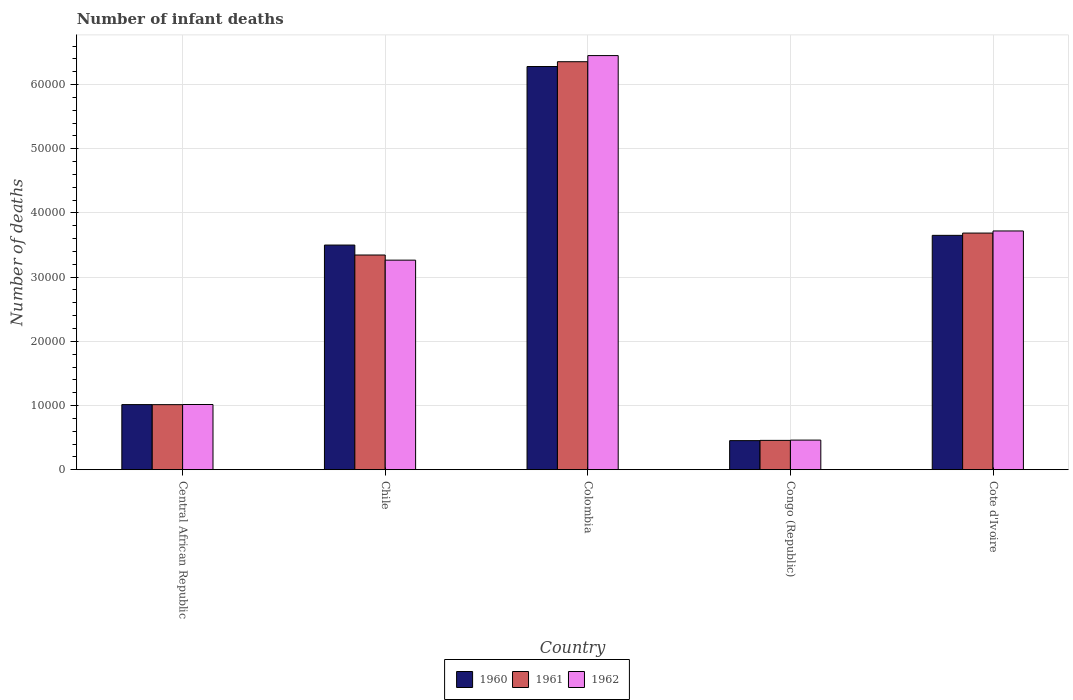How many groups of bars are there?
Keep it short and to the point. 5. Are the number of bars on each tick of the X-axis equal?
Your answer should be compact. Yes. In how many cases, is the number of bars for a given country not equal to the number of legend labels?
Keep it short and to the point. 0. What is the number of infant deaths in 1960 in Cote d'Ivoire?
Your response must be concise. 3.65e+04. Across all countries, what is the maximum number of infant deaths in 1961?
Offer a very short reply. 6.36e+04. Across all countries, what is the minimum number of infant deaths in 1960?
Ensure brevity in your answer.  4529. In which country was the number of infant deaths in 1960 maximum?
Provide a short and direct response. Colombia. In which country was the number of infant deaths in 1961 minimum?
Give a very brief answer. Congo (Republic). What is the total number of infant deaths in 1962 in the graph?
Offer a terse response. 1.49e+05. What is the difference between the number of infant deaths in 1962 in Chile and that in Colombia?
Ensure brevity in your answer.  -3.19e+04. What is the difference between the number of infant deaths in 1960 in Cote d'Ivoire and the number of infant deaths in 1962 in Congo (Republic)?
Your response must be concise. 3.19e+04. What is the average number of infant deaths in 1961 per country?
Your answer should be very brief. 2.97e+04. What is the difference between the number of infant deaths of/in 1962 and number of infant deaths of/in 1960 in Chile?
Ensure brevity in your answer.  -2350. In how many countries, is the number of infant deaths in 1960 greater than 22000?
Your answer should be compact. 3. What is the ratio of the number of infant deaths in 1962 in Central African Republic to that in Congo (Republic)?
Offer a very short reply. 2.2. What is the difference between the highest and the second highest number of infant deaths in 1961?
Offer a terse response. 3.01e+04. What is the difference between the highest and the lowest number of infant deaths in 1962?
Offer a terse response. 5.99e+04. In how many countries, is the number of infant deaths in 1960 greater than the average number of infant deaths in 1960 taken over all countries?
Ensure brevity in your answer.  3. What does the 2nd bar from the left in Congo (Republic) represents?
Your response must be concise. 1961. Is it the case that in every country, the sum of the number of infant deaths in 1960 and number of infant deaths in 1962 is greater than the number of infant deaths in 1961?
Provide a succinct answer. Yes. How many bars are there?
Your answer should be compact. 15. How many countries are there in the graph?
Make the answer very short. 5. Does the graph contain grids?
Your answer should be compact. Yes. How are the legend labels stacked?
Your answer should be compact. Horizontal. What is the title of the graph?
Make the answer very short. Number of infant deaths. What is the label or title of the X-axis?
Keep it short and to the point. Country. What is the label or title of the Y-axis?
Your response must be concise. Number of deaths. What is the Number of deaths in 1960 in Central African Republic?
Offer a very short reply. 1.01e+04. What is the Number of deaths of 1961 in Central African Republic?
Offer a terse response. 1.01e+04. What is the Number of deaths in 1962 in Central African Republic?
Give a very brief answer. 1.02e+04. What is the Number of deaths in 1960 in Chile?
Your answer should be compact. 3.50e+04. What is the Number of deaths in 1961 in Chile?
Your answer should be compact. 3.35e+04. What is the Number of deaths of 1962 in Chile?
Offer a terse response. 3.27e+04. What is the Number of deaths in 1960 in Colombia?
Offer a terse response. 6.28e+04. What is the Number of deaths in 1961 in Colombia?
Your answer should be very brief. 6.36e+04. What is the Number of deaths in 1962 in Colombia?
Ensure brevity in your answer.  6.45e+04. What is the Number of deaths in 1960 in Congo (Republic)?
Your answer should be compact. 4529. What is the Number of deaths of 1961 in Congo (Republic)?
Provide a short and direct response. 4567. What is the Number of deaths of 1962 in Congo (Republic)?
Give a very brief answer. 4612. What is the Number of deaths in 1960 in Cote d'Ivoire?
Provide a succinct answer. 3.65e+04. What is the Number of deaths in 1961 in Cote d'Ivoire?
Offer a terse response. 3.69e+04. What is the Number of deaths of 1962 in Cote d'Ivoire?
Offer a terse response. 3.72e+04. Across all countries, what is the maximum Number of deaths in 1960?
Your answer should be compact. 6.28e+04. Across all countries, what is the maximum Number of deaths of 1961?
Your response must be concise. 6.36e+04. Across all countries, what is the maximum Number of deaths of 1962?
Offer a very short reply. 6.45e+04. Across all countries, what is the minimum Number of deaths in 1960?
Give a very brief answer. 4529. Across all countries, what is the minimum Number of deaths of 1961?
Provide a succinct answer. 4567. Across all countries, what is the minimum Number of deaths of 1962?
Your answer should be very brief. 4612. What is the total Number of deaths of 1960 in the graph?
Your answer should be compact. 1.49e+05. What is the total Number of deaths of 1961 in the graph?
Your answer should be very brief. 1.49e+05. What is the total Number of deaths in 1962 in the graph?
Make the answer very short. 1.49e+05. What is the difference between the Number of deaths of 1960 in Central African Republic and that in Chile?
Keep it short and to the point. -2.49e+04. What is the difference between the Number of deaths of 1961 in Central African Republic and that in Chile?
Provide a short and direct response. -2.33e+04. What is the difference between the Number of deaths in 1962 in Central African Republic and that in Chile?
Provide a short and direct response. -2.25e+04. What is the difference between the Number of deaths in 1960 in Central African Republic and that in Colombia?
Keep it short and to the point. -5.27e+04. What is the difference between the Number of deaths in 1961 in Central African Republic and that in Colombia?
Offer a very short reply. -5.34e+04. What is the difference between the Number of deaths of 1962 in Central African Republic and that in Colombia?
Offer a very short reply. -5.44e+04. What is the difference between the Number of deaths in 1960 in Central African Republic and that in Congo (Republic)?
Provide a short and direct response. 5615. What is the difference between the Number of deaths in 1961 in Central African Republic and that in Congo (Republic)?
Your answer should be very brief. 5568. What is the difference between the Number of deaths in 1962 in Central African Republic and that in Congo (Republic)?
Your answer should be very brief. 5545. What is the difference between the Number of deaths of 1960 in Central African Republic and that in Cote d'Ivoire?
Provide a succinct answer. -2.64e+04. What is the difference between the Number of deaths in 1961 in Central African Republic and that in Cote d'Ivoire?
Make the answer very short. -2.67e+04. What is the difference between the Number of deaths of 1962 in Central African Republic and that in Cote d'Ivoire?
Ensure brevity in your answer.  -2.70e+04. What is the difference between the Number of deaths in 1960 in Chile and that in Colombia?
Make the answer very short. -2.78e+04. What is the difference between the Number of deaths in 1961 in Chile and that in Colombia?
Give a very brief answer. -3.01e+04. What is the difference between the Number of deaths in 1962 in Chile and that in Colombia?
Ensure brevity in your answer.  -3.19e+04. What is the difference between the Number of deaths of 1960 in Chile and that in Congo (Republic)?
Your answer should be compact. 3.05e+04. What is the difference between the Number of deaths of 1961 in Chile and that in Congo (Republic)?
Offer a very short reply. 2.89e+04. What is the difference between the Number of deaths of 1962 in Chile and that in Congo (Republic)?
Your answer should be very brief. 2.80e+04. What is the difference between the Number of deaths in 1960 in Chile and that in Cote d'Ivoire?
Your response must be concise. -1514. What is the difference between the Number of deaths in 1961 in Chile and that in Cote d'Ivoire?
Your answer should be very brief. -3418. What is the difference between the Number of deaths in 1962 in Chile and that in Cote d'Ivoire?
Ensure brevity in your answer.  -4547. What is the difference between the Number of deaths in 1960 in Colombia and that in Congo (Republic)?
Provide a short and direct response. 5.83e+04. What is the difference between the Number of deaths in 1961 in Colombia and that in Congo (Republic)?
Give a very brief answer. 5.90e+04. What is the difference between the Number of deaths of 1962 in Colombia and that in Congo (Republic)?
Give a very brief answer. 5.99e+04. What is the difference between the Number of deaths in 1960 in Colombia and that in Cote d'Ivoire?
Your answer should be compact. 2.63e+04. What is the difference between the Number of deaths of 1961 in Colombia and that in Cote d'Ivoire?
Provide a succinct answer. 2.67e+04. What is the difference between the Number of deaths of 1962 in Colombia and that in Cote d'Ivoire?
Offer a very short reply. 2.73e+04. What is the difference between the Number of deaths of 1960 in Congo (Republic) and that in Cote d'Ivoire?
Ensure brevity in your answer.  -3.20e+04. What is the difference between the Number of deaths in 1961 in Congo (Republic) and that in Cote d'Ivoire?
Provide a short and direct response. -3.23e+04. What is the difference between the Number of deaths of 1962 in Congo (Republic) and that in Cote d'Ivoire?
Your answer should be very brief. -3.26e+04. What is the difference between the Number of deaths in 1960 in Central African Republic and the Number of deaths in 1961 in Chile?
Provide a succinct answer. -2.33e+04. What is the difference between the Number of deaths of 1960 in Central African Republic and the Number of deaths of 1962 in Chile?
Ensure brevity in your answer.  -2.25e+04. What is the difference between the Number of deaths of 1961 in Central African Republic and the Number of deaths of 1962 in Chile?
Offer a very short reply. -2.25e+04. What is the difference between the Number of deaths of 1960 in Central African Republic and the Number of deaths of 1961 in Colombia?
Your answer should be compact. -5.34e+04. What is the difference between the Number of deaths of 1960 in Central African Republic and the Number of deaths of 1962 in Colombia?
Your answer should be very brief. -5.44e+04. What is the difference between the Number of deaths in 1961 in Central African Republic and the Number of deaths in 1962 in Colombia?
Offer a terse response. -5.44e+04. What is the difference between the Number of deaths in 1960 in Central African Republic and the Number of deaths in 1961 in Congo (Republic)?
Offer a terse response. 5577. What is the difference between the Number of deaths of 1960 in Central African Republic and the Number of deaths of 1962 in Congo (Republic)?
Your answer should be very brief. 5532. What is the difference between the Number of deaths in 1961 in Central African Republic and the Number of deaths in 1962 in Congo (Republic)?
Keep it short and to the point. 5523. What is the difference between the Number of deaths in 1960 in Central African Republic and the Number of deaths in 1961 in Cote d'Ivoire?
Ensure brevity in your answer.  -2.67e+04. What is the difference between the Number of deaths of 1960 in Central African Republic and the Number of deaths of 1962 in Cote d'Ivoire?
Give a very brief answer. -2.71e+04. What is the difference between the Number of deaths in 1961 in Central African Republic and the Number of deaths in 1962 in Cote d'Ivoire?
Make the answer very short. -2.71e+04. What is the difference between the Number of deaths in 1960 in Chile and the Number of deaths in 1961 in Colombia?
Offer a very short reply. -2.86e+04. What is the difference between the Number of deaths in 1960 in Chile and the Number of deaths in 1962 in Colombia?
Your answer should be compact. -2.95e+04. What is the difference between the Number of deaths of 1961 in Chile and the Number of deaths of 1962 in Colombia?
Your answer should be compact. -3.11e+04. What is the difference between the Number of deaths of 1960 in Chile and the Number of deaths of 1961 in Congo (Republic)?
Give a very brief answer. 3.04e+04. What is the difference between the Number of deaths of 1960 in Chile and the Number of deaths of 1962 in Congo (Republic)?
Offer a very short reply. 3.04e+04. What is the difference between the Number of deaths in 1961 in Chile and the Number of deaths in 1962 in Congo (Republic)?
Your answer should be compact. 2.88e+04. What is the difference between the Number of deaths of 1960 in Chile and the Number of deaths of 1961 in Cote d'Ivoire?
Offer a terse response. -1869. What is the difference between the Number of deaths of 1960 in Chile and the Number of deaths of 1962 in Cote d'Ivoire?
Make the answer very short. -2197. What is the difference between the Number of deaths in 1961 in Chile and the Number of deaths in 1962 in Cote d'Ivoire?
Keep it short and to the point. -3746. What is the difference between the Number of deaths of 1960 in Colombia and the Number of deaths of 1961 in Congo (Republic)?
Provide a succinct answer. 5.83e+04. What is the difference between the Number of deaths in 1960 in Colombia and the Number of deaths in 1962 in Congo (Republic)?
Provide a succinct answer. 5.82e+04. What is the difference between the Number of deaths in 1961 in Colombia and the Number of deaths in 1962 in Congo (Republic)?
Offer a very short reply. 5.90e+04. What is the difference between the Number of deaths of 1960 in Colombia and the Number of deaths of 1961 in Cote d'Ivoire?
Make the answer very short. 2.60e+04. What is the difference between the Number of deaths of 1960 in Colombia and the Number of deaths of 1962 in Cote d'Ivoire?
Your answer should be very brief. 2.56e+04. What is the difference between the Number of deaths of 1961 in Colombia and the Number of deaths of 1962 in Cote d'Ivoire?
Provide a succinct answer. 2.64e+04. What is the difference between the Number of deaths in 1960 in Congo (Republic) and the Number of deaths in 1961 in Cote d'Ivoire?
Your answer should be compact. -3.23e+04. What is the difference between the Number of deaths in 1960 in Congo (Republic) and the Number of deaths in 1962 in Cote d'Ivoire?
Offer a very short reply. -3.27e+04. What is the difference between the Number of deaths of 1961 in Congo (Republic) and the Number of deaths of 1962 in Cote d'Ivoire?
Your answer should be compact. -3.26e+04. What is the average Number of deaths in 1960 per country?
Your answer should be very brief. 2.98e+04. What is the average Number of deaths of 1961 per country?
Offer a terse response. 2.97e+04. What is the average Number of deaths of 1962 per country?
Your answer should be very brief. 2.98e+04. What is the difference between the Number of deaths of 1960 and Number of deaths of 1961 in Central African Republic?
Offer a terse response. 9. What is the difference between the Number of deaths in 1961 and Number of deaths in 1962 in Central African Republic?
Provide a succinct answer. -22. What is the difference between the Number of deaths in 1960 and Number of deaths in 1961 in Chile?
Your answer should be very brief. 1549. What is the difference between the Number of deaths of 1960 and Number of deaths of 1962 in Chile?
Make the answer very short. 2350. What is the difference between the Number of deaths of 1961 and Number of deaths of 1962 in Chile?
Your response must be concise. 801. What is the difference between the Number of deaths of 1960 and Number of deaths of 1961 in Colombia?
Make the answer very short. -749. What is the difference between the Number of deaths in 1960 and Number of deaths in 1962 in Colombia?
Ensure brevity in your answer.  -1705. What is the difference between the Number of deaths in 1961 and Number of deaths in 1962 in Colombia?
Offer a terse response. -956. What is the difference between the Number of deaths in 1960 and Number of deaths in 1961 in Congo (Republic)?
Keep it short and to the point. -38. What is the difference between the Number of deaths of 1960 and Number of deaths of 1962 in Congo (Republic)?
Your response must be concise. -83. What is the difference between the Number of deaths in 1961 and Number of deaths in 1962 in Congo (Republic)?
Offer a terse response. -45. What is the difference between the Number of deaths of 1960 and Number of deaths of 1961 in Cote d'Ivoire?
Provide a succinct answer. -355. What is the difference between the Number of deaths in 1960 and Number of deaths in 1962 in Cote d'Ivoire?
Offer a very short reply. -683. What is the difference between the Number of deaths in 1961 and Number of deaths in 1962 in Cote d'Ivoire?
Your answer should be very brief. -328. What is the ratio of the Number of deaths of 1960 in Central African Republic to that in Chile?
Give a very brief answer. 0.29. What is the ratio of the Number of deaths of 1961 in Central African Republic to that in Chile?
Offer a very short reply. 0.3. What is the ratio of the Number of deaths in 1962 in Central African Republic to that in Chile?
Your answer should be very brief. 0.31. What is the ratio of the Number of deaths of 1960 in Central African Republic to that in Colombia?
Provide a short and direct response. 0.16. What is the ratio of the Number of deaths in 1961 in Central African Republic to that in Colombia?
Give a very brief answer. 0.16. What is the ratio of the Number of deaths in 1962 in Central African Republic to that in Colombia?
Your answer should be compact. 0.16. What is the ratio of the Number of deaths of 1960 in Central African Republic to that in Congo (Republic)?
Ensure brevity in your answer.  2.24. What is the ratio of the Number of deaths in 1961 in Central African Republic to that in Congo (Republic)?
Provide a succinct answer. 2.22. What is the ratio of the Number of deaths of 1962 in Central African Republic to that in Congo (Republic)?
Your answer should be very brief. 2.2. What is the ratio of the Number of deaths in 1960 in Central African Republic to that in Cote d'Ivoire?
Your answer should be compact. 0.28. What is the ratio of the Number of deaths in 1961 in Central African Republic to that in Cote d'Ivoire?
Your answer should be very brief. 0.27. What is the ratio of the Number of deaths in 1962 in Central African Republic to that in Cote d'Ivoire?
Give a very brief answer. 0.27. What is the ratio of the Number of deaths in 1960 in Chile to that in Colombia?
Give a very brief answer. 0.56. What is the ratio of the Number of deaths of 1961 in Chile to that in Colombia?
Offer a terse response. 0.53. What is the ratio of the Number of deaths of 1962 in Chile to that in Colombia?
Offer a very short reply. 0.51. What is the ratio of the Number of deaths in 1960 in Chile to that in Congo (Republic)?
Keep it short and to the point. 7.73. What is the ratio of the Number of deaths of 1961 in Chile to that in Congo (Republic)?
Your answer should be very brief. 7.32. What is the ratio of the Number of deaths in 1962 in Chile to that in Congo (Republic)?
Offer a terse response. 7.08. What is the ratio of the Number of deaths in 1960 in Chile to that in Cote d'Ivoire?
Offer a very short reply. 0.96. What is the ratio of the Number of deaths of 1961 in Chile to that in Cote d'Ivoire?
Your answer should be compact. 0.91. What is the ratio of the Number of deaths of 1962 in Chile to that in Cote d'Ivoire?
Make the answer very short. 0.88. What is the ratio of the Number of deaths of 1960 in Colombia to that in Congo (Republic)?
Provide a succinct answer. 13.87. What is the ratio of the Number of deaths of 1961 in Colombia to that in Congo (Republic)?
Ensure brevity in your answer.  13.92. What is the ratio of the Number of deaths of 1962 in Colombia to that in Congo (Republic)?
Your answer should be compact. 13.99. What is the ratio of the Number of deaths of 1960 in Colombia to that in Cote d'Ivoire?
Provide a short and direct response. 1.72. What is the ratio of the Number of deaths in 1961 in Colombia to that in Cote d'Ivoire?
Offer a terse response. 1.72. What is the ratio of the Number of deaths in 1962 in Colombia to that in Cote d'Ivoire?
Make the answer very short. 1.73. What is the ratio of the Number of deaths of 1960 in Congo (Republic) to that in Cote d'Ivoire?
Ensure brevity in your answer.  0.12. What is the ratio of the Number of deaths in 1961 in Congo (Republic) to that in Cote d'Ivoire?
Your answer should be very brief. 0.12. What is the ratio of the Number of deaths of 1962 in Congo (Republic) to that in Cote d'Ivoire?
Provide a short and direct response. 0.12. What is the difference between the highest and the second highest Number of deaths in 1960?
Give a very brief answer. 2.63e+04. What is the difference between the highest and the second highest Number of deaths of 1961?
Your answer should be very brief. 2.67e+04. What is the difference between the highest and the second highest Number of deaths in 1962?
Provide a short and direct response. 2.73e+04. What is the difference between the highest and the lowest Number of deaths in 1960?
Your response must be concise. 5.83e+04. What is the difference between the highest and the lowest Number of deaths in 1961?
Provide a succinct answer. 5.90e+04. What is the difference between the highest and the lowest Number of deaths in 1962?
Make the answer very short. 5.99e+04. 